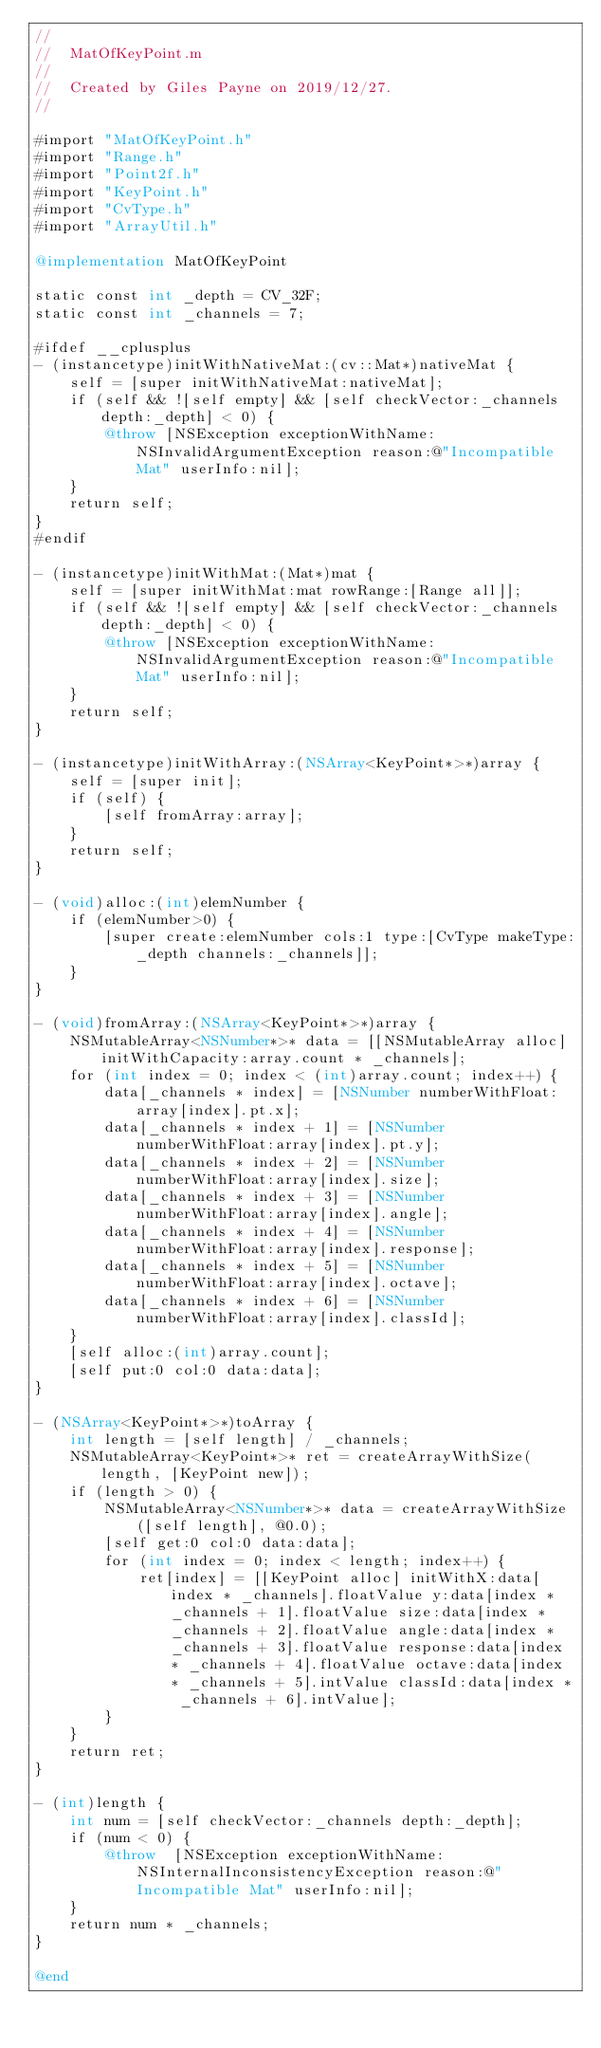Convert code to text. <code><loc_0><loc_0><loc_500><loc_500><_ObjectiveC_>//
//  MatOfKeyPoint.m
//
//  Created by Giles Payne on 2019/12/27.
//

#import "MatOfKeyPoint.h"
#import "Range.h"
#import "Point2f.h"
#import "KeyPoint.h"
#import "CvType.h"
#import "ArrayUtil.h"

@implementation MatOfKeyPoint

static const int _depth = CV_32F;
static const int _channels = 7;

#ifdef __cplusplus
- (instancetype)initWithNativeMat:(cv::Mat*)nativeMat {
    self = [super initWithNativeMat:nativeMat];
    if (self && ![self empty] && [self checkVector:_channels depth:_depth] < 0) {
        @throw [NSException exceptionWithName:NSInvalidArgumentException reason:@"Incompatible Mat" userInfo:nil];
    }
    return self;
}
#endif

- (instancetype)initWithMat:(Mat*)mat {
    self = [super initWithMat:mat rowRange:[Range all]];
    if (self && ![self empty] && [self checkVector:_channels depth:_depth] < 0) {
        @throw [NSException exceptionWithName:NSInvalidArgumentException reason:@"Incompatible Mat" userInfo:nil];
    }
    return self;
}

- (instancetype)initWithArray:(NSArray<KeyPoint*>*)array {
    self = [super init];
    if (self) {
        [self fromArray:array];
    }
    return self;
}

- (void)alloc:(int)elemNumber {
    if (elemNumber>0) {
        [super create:elemNumber cols:1 type:[CvType makeType:_depth channels:_channels]];
    }
}

- (void)fromArray:(NSArray<KeyPoint*>*)array {
    NSMutableArray<NSNumber*>* data = [[NSMutableArray alloc] initWithCapacity:array.count * _channels];
    for (int index = 0; index < (int)array.count; index++) {
        data[_channels * index] = [NSNumber numberWithFloat:array[index].pt.x];
        data[_channels * index + 1] = [NSNumber numberWithFloat:array[index].pt.y];
        data[_channels * index + 2] = [NSNumber numberWithFloat:array[index].size];
        data[_channels * index + 3] = [NSNumber numberWithFloat:array[index].angle];
        data[_channels * index + 4] = [NSNumber numberWithFloat:array[index].response];
        data[_channels * index + 5] = [NSNumber numberWithFloat:array[index].octave];
        data[_channels * index + 6] = [NSNumber numberWithFloat:array[index].classId];
    }
    [self alloc:(int)array.count];
    [self put:0 col:0 data:data];
}

- (NSArray<KeyPoint*>*)toArray {
    int length = [self length] / _channels;
    NSMutableArray<KeyPoint*>* ret = createArrayWithSize(length, [KeyPoint new]);
    if (length > 0) {
        NSMutableArray<NSNumber*>* data = createArrayWithSize([self length], @0.0);
        [self get:0 col:0 data:data];
        for (int index = 0; index < length; index++) {
            ret[index] = [[KeyPoint alloc] initWithX:data[index * _channels].floatValue y:data[index * _channels + 1].floatValue size:data[index * _channels + 2].floatValue angle:data[index * _channels + 3].floatValue response:data[index * _channels + 4].floatValue octave:data[index * _channels + 5].intValue classId:data[index * _channels + 6].intValue];
        }
    }
    return ret;
}

- (int)length {
    int num = [self checkVector:_channels depth:_depth];
    if (num < 0) {
        @throw  [NSException exceptionWithName:NSInternalInconsistencyException reason:@"Incompatible Mat" userInfo:nil];
    }
    return num * _channels;
}

@end
</code> 